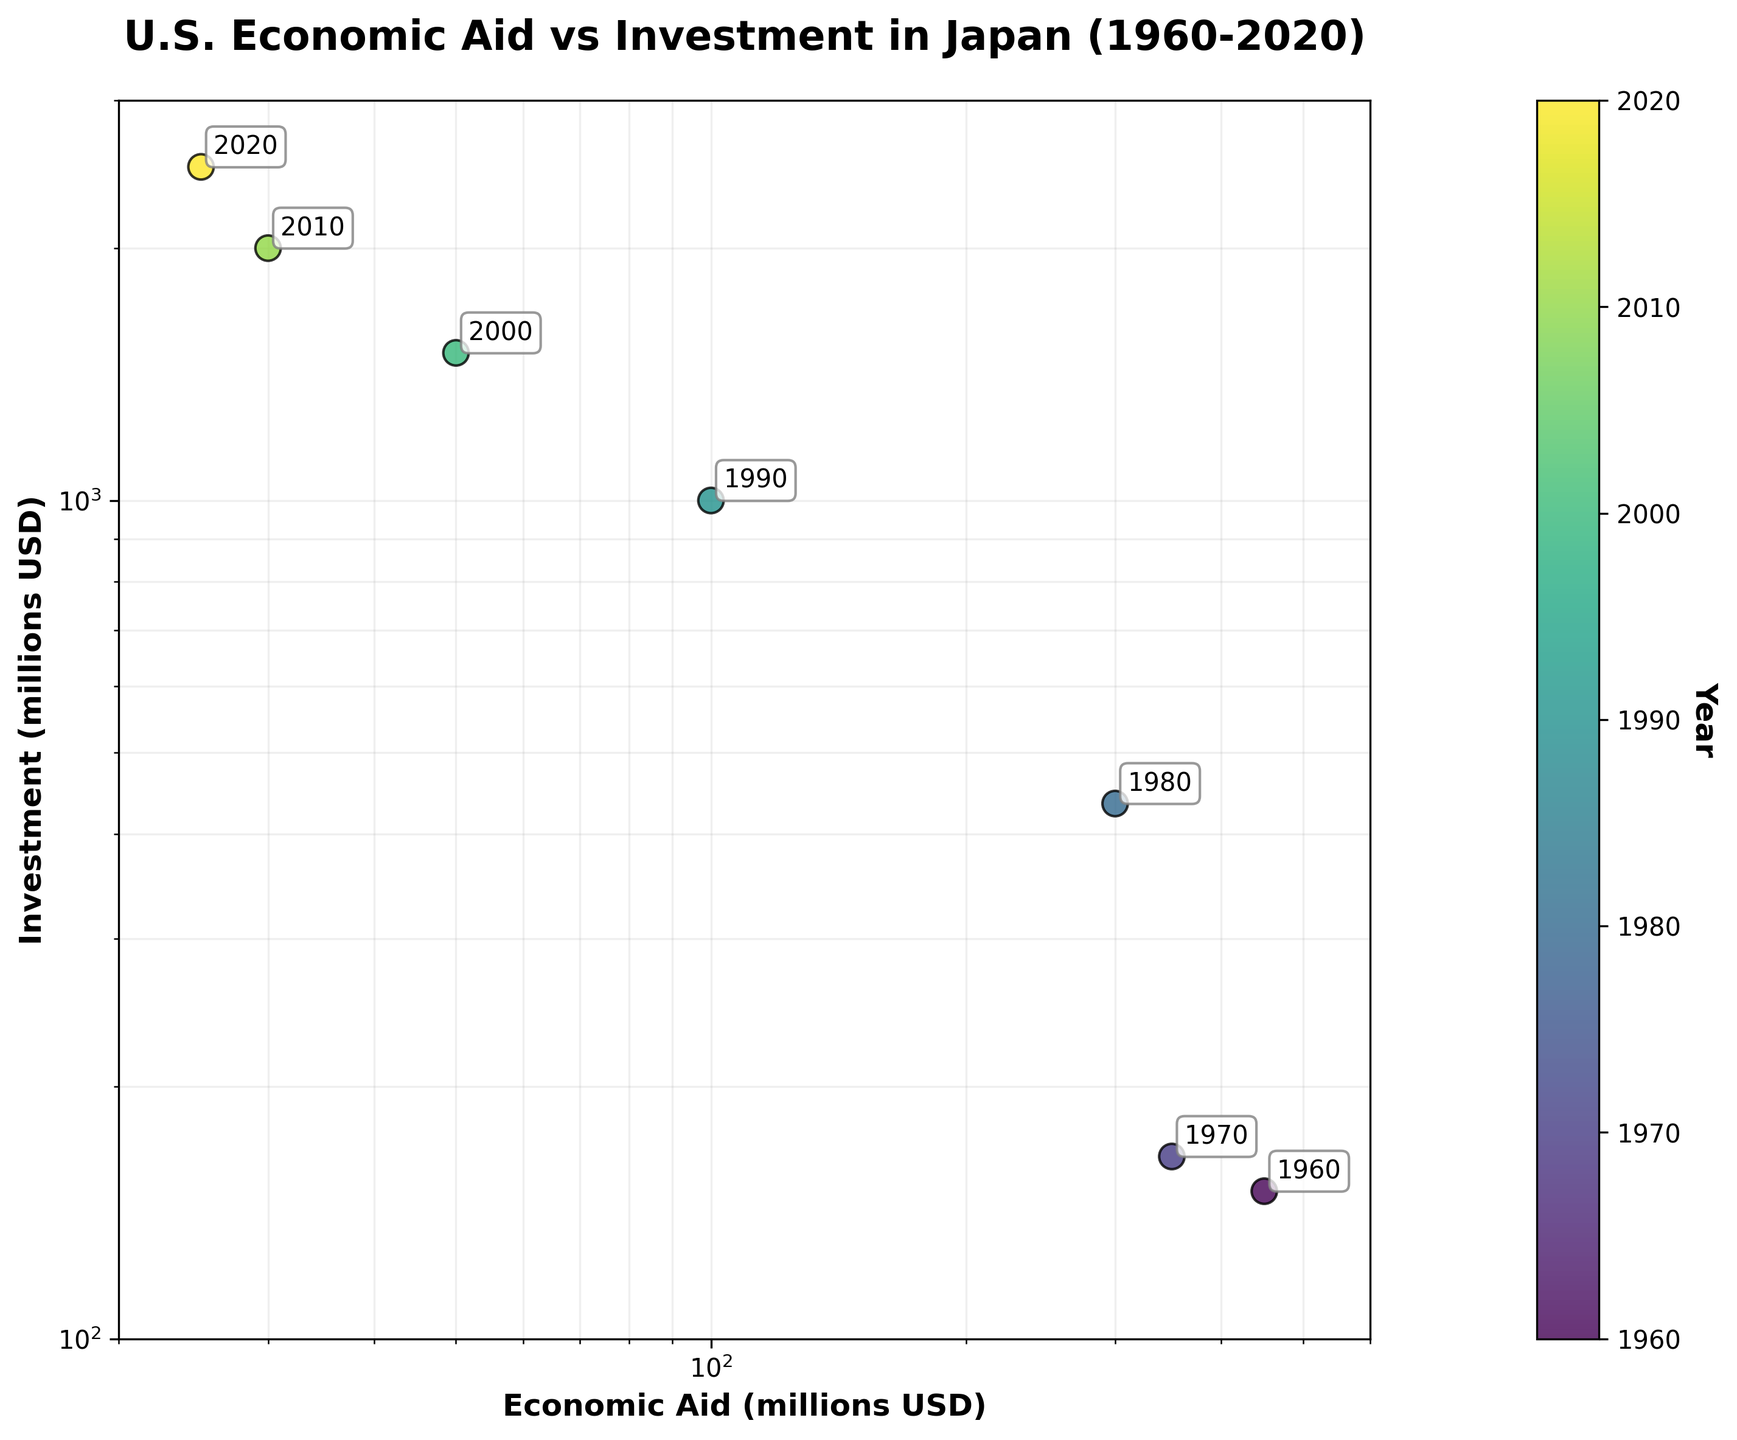What is the title of the figure? The title is in bold and positioned at the top of the figure. It sums up the overall content depicted by the plot. The title reads "U.S. Economic Aid vs Investment in Japan (1960-2020)."
Answer: U.S. Economic Aid vs Investment in Japan (1960-2020) What are the axes labels in the figure? The x-axis label is "Economic Aid (millions USD)" and the y-axis label is "Investment (millions USD)", both in bold for clarity.
Answer: Economic Aid (millions USD) and Investment (millions USD) How many data points are there in the figure? There are seven different years depicted in the figure with each year represented by a distinct data point.
Answer: 7 What is indicated by the color bar on the right side of the plot? The color bar represents the years, ranging from 1960 to 2020. The colors change along the viridis colormap to indicate different years.
Answer: Years from 1960 to 2020 What is the total of Economic Aid provided by the U.S. in the decades 1960 and 1970? Adding values from 1960 and 1970: 450 million USD (1960) + 350 million USD (1970) = 800 million USD.
Answer: 800 million USD What is the average Investment amount from the U.S. in Japan for decades 1990, 2000, and 2010? Sum the investment amounts for 1990 (1000 million USD), 2000 (1500 million USD), and 2010 (2000 million USD), then divide by 3: (1000 + 1500 + 2000)/3 = 4500/3 = 1500 million USD.
Answer: 1500 million USD In which year was U.S. Economic Aid to Japan the highest? The highest point on the x-axis (Economic Aid) corresponds to 1960 with 450 million USD.
Answer: 1960 How does the Investment value in 2020 compare to that in 1990? The investment in 2020 is 2500 million USD, while in 1990 it was 1000 million USD. Thus, 2020's investment is significantly higher.
Answer: 2020 is higher Which year witnessed the steepest decline in Economic Aid? The most noticeable reduction in Economic Aid occurs between consecutive years when dropping from 300 million USD in 1980 to 100 million USD in 1990.
Answer: Between 1980 and 1990 Why are both the x and y axes on a log scale? Log scales are used for both axes to better visualize the wide range of data values, from small to large. It helps in examining the multiplicative relationships between Economic Aid and Investment.
Answer: To visualize the wide range of data values and multiplicative relationships Which years appear to be outliers in terms of the relationship between Economic Aid and Investment? Visual inspection indicates the 1960s and 2020 as potential outliers, as 1960 has the highest Economic Aid in a period with otherwise decreasing values, and 2020 has a high investment with very low aid.
Answer: 1960 and 2020 